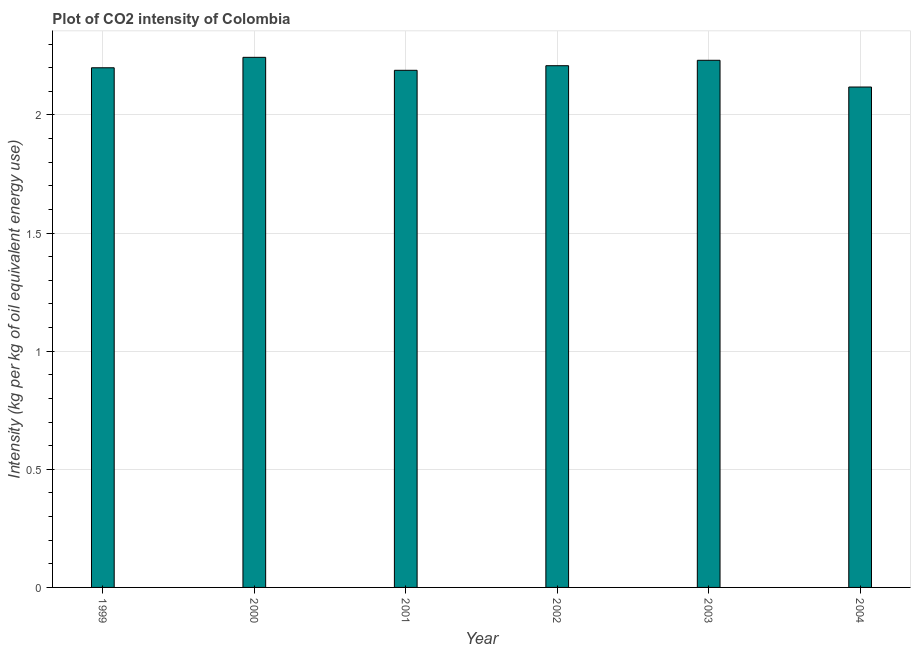Does the graph contain any zero values?
Provide a succinct answer. No. Does the graph contain grids?
Keep it short and to the point. Yes. What is the title of the graph?
Ensure brevity in your answer.  Plot of CO2 intensity of Colombia. What is the label or title of the X-axis?
Your answer should be compact. Year. What is the label or title of the Y-axis?
Give a very brief answer. Intensity (kg per kg of oil equivalent energy use). What is the co2 intensity in 2000?
Make the answer very short. 2.24. Across all years, what is the maximum co2 intensity?
Give a very brief answer. 2.24. Across all years, what is the minimum co2 intensity?
Give a very brief answer. 2.12. What is the sum of the co2 intensity?
Provide a short and direct response. 13.19. What is the difference between the co2 intensity in 2000 and 2001?
Provide a short and direct response. 0.06. What is the average co2 intensity per year?
Ensure brevity in your answer.  2.2. What is the median co2 intensity?
Provide a short and direct response. 2.2. Is the difference between the co2 intensity in 2001 and 2004 greater than the difference between any two years?
Ensure brevity in your answer.  No. What is the difference between the highest and the second highest co2 intensity?
Provide a succinct answer. 0.01. Is the sum of the co2 intensity in 2000 and 2002 greater than the maximum co2 intensity across all years?
Offer a terse response. Yes. What is the difference between the highest and the lowest co2 intensity?
Give a very brief answer. 0.13. In how many years, is the co2 intensity greater than the average co2 intensity taken over all years?
Your response must be concise. 4. How many bars are there?
Your answer should be very brief. 6. Are the values on the major ticks of Y-axis written in scientific E-notation?
Your response must be concise. No. What is the Intensity (kg per kg of oil equivalent energy use) in 1999?
Provide a succinct answer. 2.2. What is the Intensity (kg per kg of oil equivalent energy use) of 2000?
Your response must be concise. 2.24. What is the Intensity (kg per kg of oil equivalent energy use) in 2001?
Offer a terse response. 2.19. What is the Intensity (kg per kg of oil equivalent energy use) of 2002?
Your response must be concise. 2.21. What is the Intensity (kg per kg of oil equivalent energy use) of 2003?
Your answer should be very brief. 2.23. What is the Intensity (kg per kg of oil equivalent energy use) in 2004?
Provide a succinct answer. 2.12. What is the difference between the Intensity (kg per kg of oil equivalent energy use) in 1999 and 2000?
Provide a succinct answer. -0.04. What is the difference between the Intensity (kg per kg of oil equivalent energy use) in 1999 and 2001?
Keep it short and to the point. 0.01. What is the difference between the Intensity (kg per kg of oil equivalent energy use) in 1999 and 2002?
Ensure brevity in your answer.  -0.01. What is the difference between the Intensity (kg per kg of oil equivalent energy use) in 1999 and 2003?
Your answer should be very brief. -0.03. What is the difference between the Intensity (kg per kg of oil equivalent energy use) in 1999 and 2004?
Offer a terse response. 0.08. What is the difference between the Intensity (kg per kg of oil equivalent energy use) in 2000 and 2001?
Your response must be concise. 0.05. What is the difference between the Intensity (kg per kg of oil equivalent energy use) in 2000 and 2002?
Give a very brief answer. 0.04. What is the difference between the Intensity (kg per kg of oil equivalent energy use) in 2000 and 2003?
Your answer should be very brief. 0.01. What is the difference between the Intensity (kg per kg of oil equivalent energy use) in 2000 and 2004?
Offer a very short reply. 0.13. What is the difference between the Intensity (kg per kg of oil equivalent energy use) in 2001 and 2002?
Provide a short and direct response. -0.02. What is the difference between the Intensity (kg per kg of oil equivalent energy use) in 2001 and 2003?
Your response must be concise. -0.04. What is the difference between the Intensity (kg per kg of oil equivalent energy use) in 2001 and 2004?
Offer a terse response. 0.07. What is the difference between the Intensity (kg per kg of oil equivalent energy use) in 2002 and 2003?
Keep it short and to the point. -0.02. What is the difference between the Intensity (kg per kg of oil equivalent energy use) in 2002 and 2004?
Make the answer very short. 0.09. What is the difference between the Intensity (kg per kg of oil equivalent energy use) in 2003 and 2004?
Ensure brevity in your answer.  0.11. What is the ratio of the Intensity (kg per kg of oil equivalent energy use) in 1999 to that in 2001?
Your answer should be compact. 1. What is the ratio of the Intensity (kg per kg of oil equivalent energy use) in 1999 to that in 2002?
Offer a terse response. 1. What is the ratio of the Intensity (kg per kg of oil equivalent energy use) in 1999 to that in 2004?
Offer a terse response. 1.04. What is the ratio of the Intensity (kg per kg of oil equivalent energy use) in 2000 to that in 2001?
Provide a succinct answer. 1.02. What is the ratio of the Intensity (kg per kg of oil equivalent energy use) in 2000 to that in 2002?
Make the answer very short. 1.02. What is the ratio of the Intensity (kg per kg of oil equivalent energy use) in 2000 to that in 2004?
Provide a succinct answer. 1.06. What is the ratio of the Intensity (kg per kg of oil equivalent energy use) in 2001 to that in 2002?
Keep it short and to the point. 0.99. What is the ratio of the Intensity (kg per kg of oil equivalent energy use) in 2001 to that in 2004?
Your answer should be compact. 1.03. What is the ratio of the Intensity (kg per kg of oil equivalent energy use) in 2002 to that in 2003?
Give a very brief answer. 0.99. What is the ratio of the Intensity (kg per kg of oil equivalent energy use) in 2002 to that in 2004?
Offer a very short reply. 1.04. What is the ratio of the Intensity (kg per kg of oil equivalent energy use) in 2003 to that in 2004?
Ensure brevity in your answer.  1.05. 